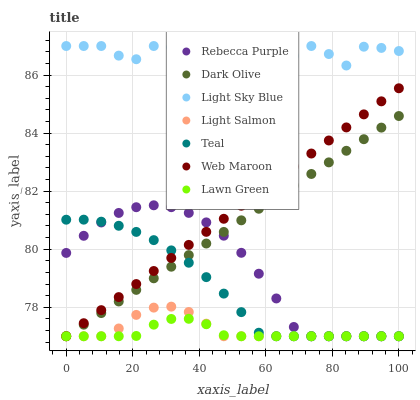Does Lawn Green have the minimum area under the curve?
Answer yes or no. Yes. Does Light Sky Blue have the maximum area under the curve?
Answer yes or no. Yes. Does Light Salmon have the minimum area under the curve?
Answer yes or no. No. Does Light Salmon have the maximum area under the curve?
Answer yes or no. No. Is Web Maroon the smoothest?
Answer yes or no. Yes. Is Light Sky Blue the roughest?
Answer yes or no. Yes. Is Light Salmon the smoothest?
Answer yes or no. No. Is Light Salmon the roughest?
Answer yes or no. No. Does Lawn Green have the lowest value?
Answer yes or no. Yes. Does Light Sky Blue have the lowest value?
Answer yes or no. No. Does Light Sky Blue have the highest value?
Answer yes or no. Yes. Does Light Salmon have the highest value?
Answer yes or no. No. Is Rebecca Purple less than Light Sky Blue?
Answer yes or no. Yes. Is Light Sky Blue greater than Web Maroon?
Answer yes or no. Yes. Does Web Maroon intersect Dark Olive?
Answer yes or no. Yes. Is Web Maroon less than Dark Olive?
Answer yes or no. No. Is Web Maroon greater than Dark Olive?
Answer yes or no. No. Does Rebecca Purple intersect Light Sky Blue?
Answer yes or no. No. 